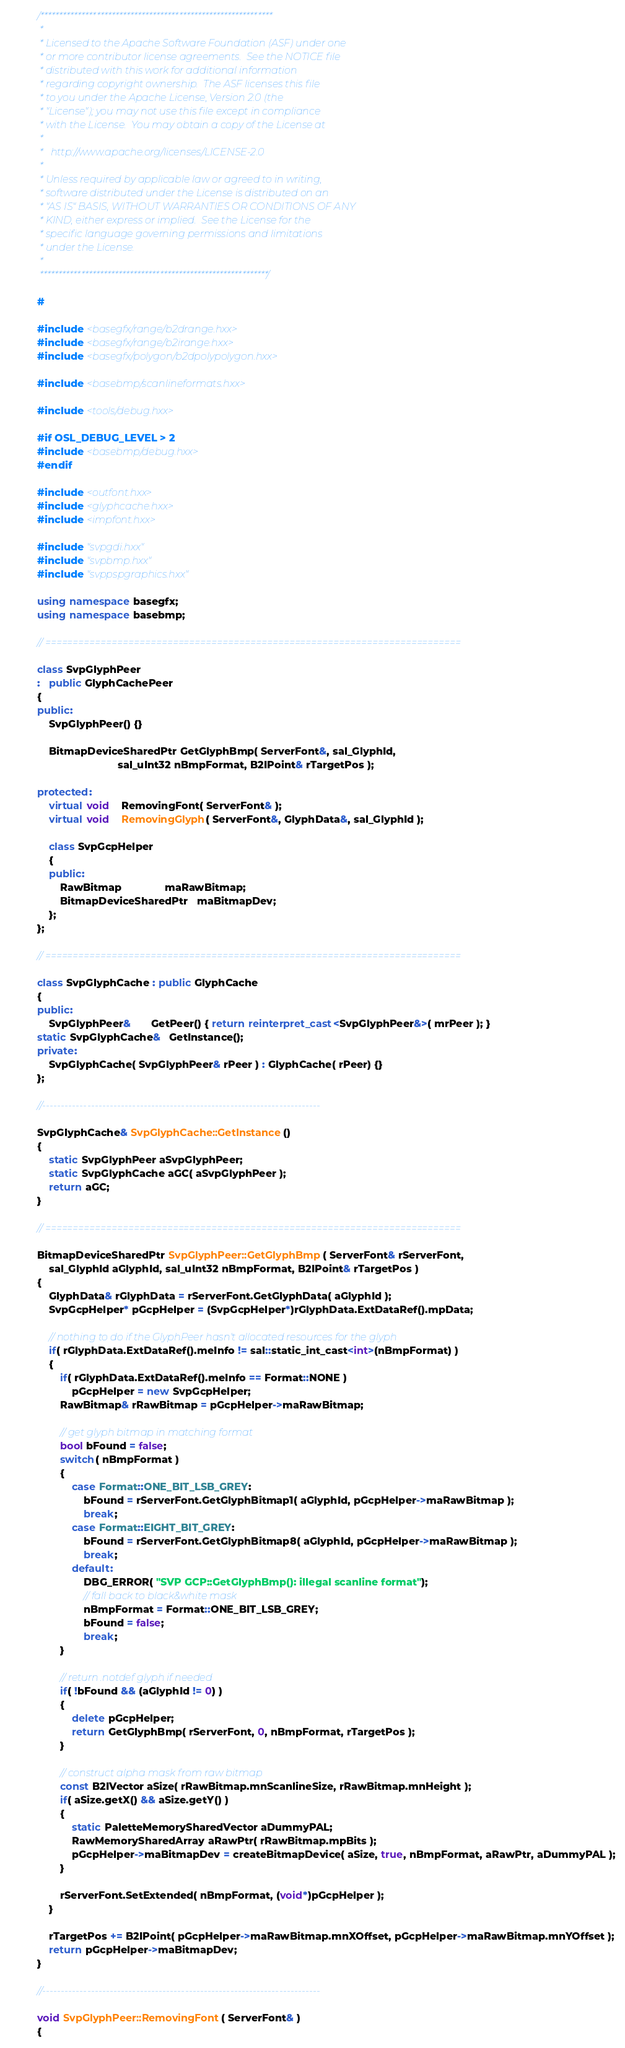<code> <loc_0><loc_0><loc_500><loc_500><_C++_>/**************************************************************
 * 
 * Licensed to the Apache Software Foundation (ASF) under one
 * or more contributor license agreements.  See the NOTICE file
 * distributed with this work for additional information
 * regarding copyright ownership.  The ASF licenses this file
 * to you under the Apache License, Version 2.0 (the
 * "License"); you may not use this file except in compliance
 * with the License.  You may obtain a copy of the License at
 * 
 *   http://www.apache.org/licenses/LICENSE-2.0
 * 
 * Unless required by applicable law or agreed to in writing,
 * software distributed under the License is distributed on an
 * "AS IS" BASIS, WITHOUT WARRANTIES OR CONDITIONS OF ANY
 * KIND, either express or implied.  See the License for the
 * specific language governing permissions and limitations
 * under the License.
 * 
 *************************************************************/

#

#include <basegfx/range/b2drange.hxx>
#include <basegfx/range/b2irange.hxx>
#include <basegfx/polygon/b2dpolypolygon.hxx>

#include <basebmp/scanlineformats.hxx>

#include <tools/debug.hxx>

#if OSL_DEBUG_LEVEL > 2
#include <basebmp/debug.hxx>
#endif

#include <outfont.hxx>
#include <glyphcache.hxx>
#include <impfont.hxx>

#include "svpgdi.hxx"
#include "svpbmp.hxx"
#include "svppspgraphics.hxx"

using namespace basegfx;
using namespace basebmp;

// ===========================================================================

class SvpGlyphPeer
:   public GlyphCachePeer
{
public:
    SvpGlyphPeer() {}

    BitmapDeviceSharedPtr GetGlyphBmp( ServerFont&, sal_GlyphId,
                            sal_uInt32 nBmpFormat, B2IPoint& rTargetPos );

protected:
    virtual void    RemovingFont( ServerFont& );
    virtual void    RemovingGlyph( ServerFont&, GlyphData&, sal_GlyphId );

    class SvpGcpHelper
    {
    public:
        RawBitmap               maRawBitmap;
        BitmapDeviceSharedPtr   maBitmapDev;
    };
};

// ===========================================================================

class SvpGlyphCache : public GlyphCache
{
public:
    SvpGlyphPeer&       GetPeer() { return reinterpret_cast<SvpGlyphPeer&>( mrPeer ); }
static SvpGlyphCache&   GetInstance();
private:
    SvpGlyphCache( SvpGlyphPeer& rPeer ) : GlyphCache( rPeer) {}
};

//--------------------------------------------------------------------------

SvpGlyphCache& SvpGlyphCache::GetInstance()
{
    static SvpGlyphPeer aSvpGlyphPeer;
    static SvpGlyphCache aGC( aSvpGlyphPeer );
    return aGC; 
}

// ===========================================================================

BitmapDeviceSharedPtr SvpGlyphPeer::GetGlyphBmp( ServerFont& rServerFont,
    sal_GlyphId aGlyphId, sal_uInt32 nBmpFormat, B2IPoint& rTargetPos )
{
    GlyphData& rGlyphData = rServerFont.GetGlyphData( aGlyphId );
    SvpGcpHelper* pGcpHelper = (SvpGcpHelper*)rGlyphData.ExtDataRef().mpData;

    // nothing to do if the GlyphPeer hasn't allocated resources for the glyph
    if( rGlyphData.ExtDataRef().meInfo != sal::static_int_cast<int>(nBmpFormat) )
    {
        if( rGlyphData.ExtDataRef().meInfo == Format::NONE )
            pGcpHelper = new SvpGcpHelper;
        RawBitmap& rRawBitmap = pGcpHelper->maRawBitmap;

        // get glyph bitmap in matching format
        bool bFound = false;
        switch( nBmpFormat )
        {
            case Format::ONE_BIT_LSB_GREY:
                bFound = rServerFont.GetGlyphBitmap1( aGlyphId, pGcpHelper->maRawBitmap );
                break;
            case Format::EIGHT_BIT_GREY:
                bFound = rServerFont.GetGlyphBitmap8( aGlyphId, pGcpHelper->maRawBitmap );
                break;
            default:
                DBG_ERROR( "SVP GCP::GetGlyphBmp(): illegal scanline format");
                // fall back to black&white mask
                nBmpFormat = Format::ONE_BIT_LSB_GREY;
                bFound = false;
                break;
        }

        // return .notdef glyph if needed
        if( !bFound && (aGlyphId != 0) )
        {
            delete pGcpHelper;
            return GetGlyphBmp( rServerFont, 0, nBmpFormat, rTargetPos );
        }

        // construct alpha mask from raw bitmap
        const B2IVector aSize( rRawBitmap.mnScanlineSize, rRawBitmap.mnHeight );
        if( aSize.getX() && aSize.getY() )
        {
            static PaletteMemorySharedVector aDummyPAL;
            RawMemorySharedArray aRawPtr( rRawBitmap.mpBits );
            pGcpHelper->maBitmapDev = createBitmapDevice( aSize, true, nBmpFormat, aRawPtr, aDummyPAL );
        }

        rServerFont.SetExtended( nBmpFormat, (void*)pGcpHelper );
    }

    rTargetPos += B2IPoint( pGcpHelper->maRawBitmap.mnXOffset, pGcpHelper->maRawBitmap.mnYOffset );
    return pGcpHelper->maBitmapDev;
}

//--------------------------------------------------------------------------

void SvpGlyphPeer::RemovingFont( ServerFont& )
{</code> 